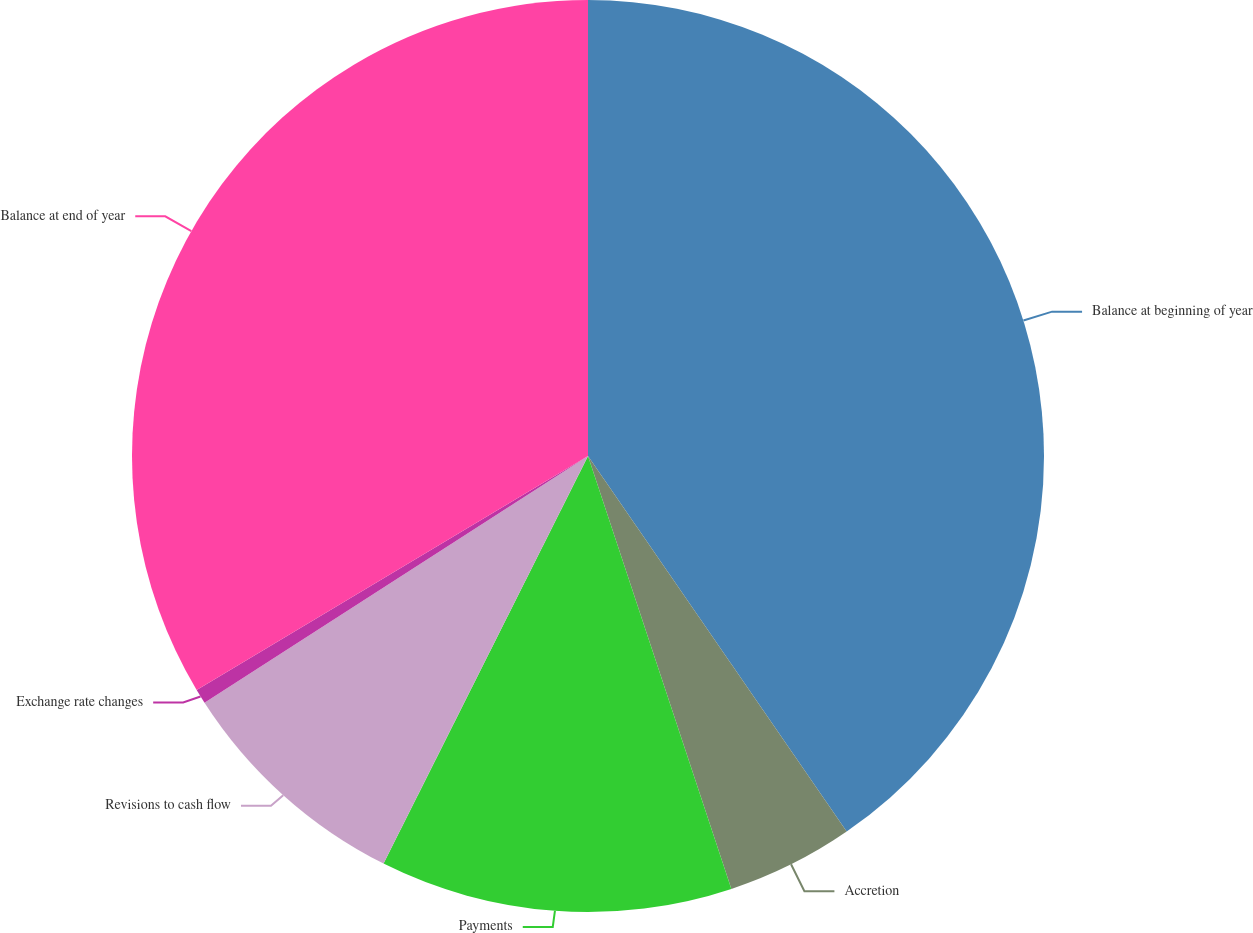Convert chart to OTSL. <chart><loc_0><loc_0><loc_500><loc_500><pie_chart><fcel>Balance at beginning of year<fcel>Accretion<fcel>Payments<fcel>Revisions to cash flow<fcel>Exchange rate changes<fcel>Balance at end of year<nl><fcel>40.4%<fcel>4.51%<fcel>12.49%<fcel>8.5%<fcel>0.52%<fcel>33.58%<nl></chart> 